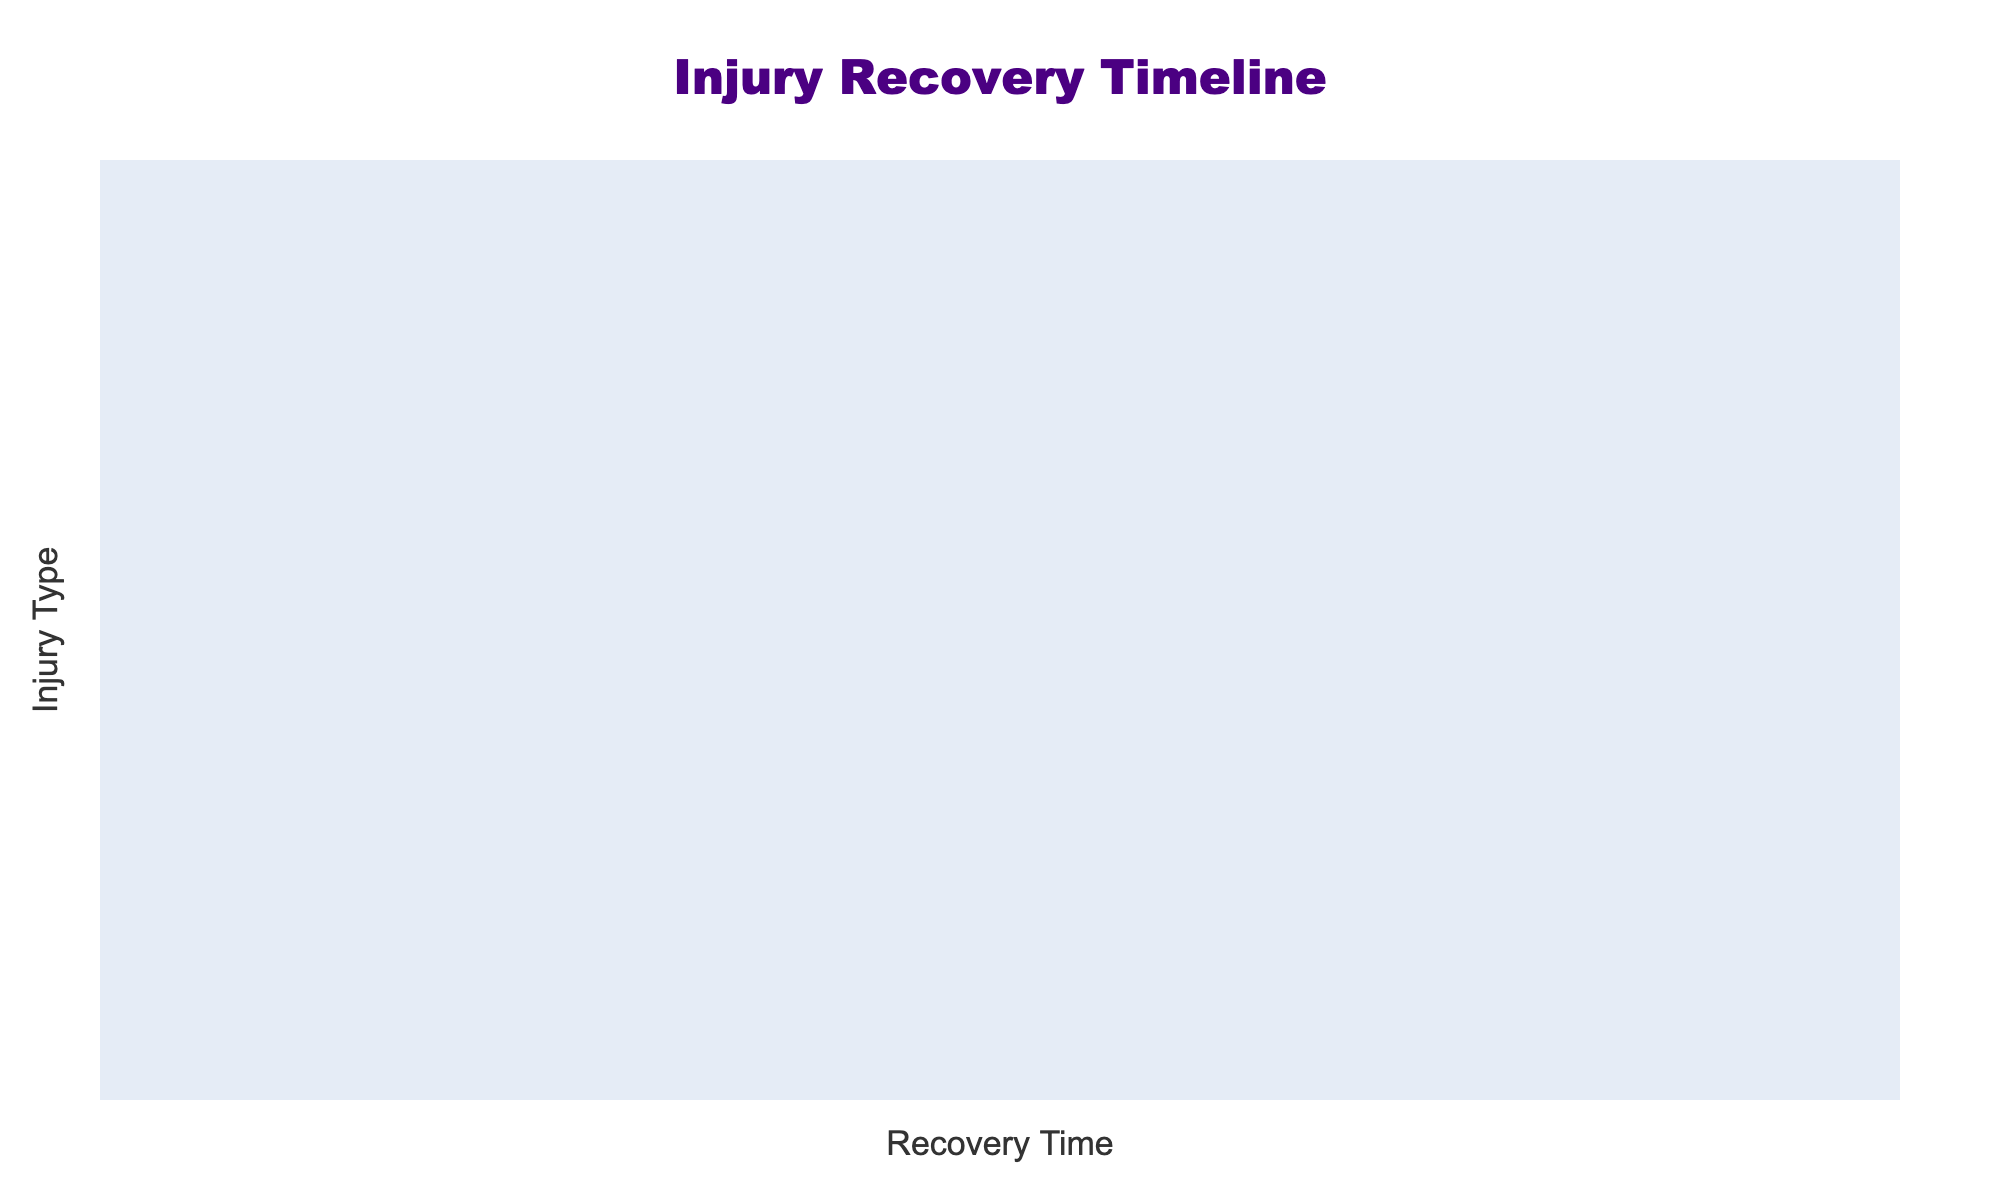What is the recovery percentage for an ankle sprain after 2 weeks? The table shows that the recovery percentage for an ankle sprain after 2 weeks is 60%.
Answer: 60% Which injury has the slowest initial recovery after 1 week? Observing the recovery percentages at 1 week, the ACL Tear shows 0% recovery, which is the lowest compared to other injuries.
Answer: ACL Tear What is the recovery percentage for a hamstring strain after 8 weeks, and how does it compare to a groin strain? The recovery percentage for a hamstring strain after 8 weeks is 90%, while the groin strain has a recovery percentage of 95% at the same time. Thus, the groin strain has a 5% higher recovery percentage than the hamstring strain after 8 weeks.
Answer: Hamstring Strain: 90%, Groin Strain: 95% True or False: A fractured collarbone has a 60% recovery after 8 weeks. The table indicates that a fractured collarbone has a recovery percentage of 60% after 8 weeks, making the statement true.
Answer: True What is the difference in recovery percentages between a concussion and a meniscus tear at 4 weeks? The concussion recovery rate at 4 weeks is 80%, while the meniscus tear is at 40%. The difference is calculated as 80% - 40% = 40%.
Answer: 40% List the two injuries with identical recovery percentages at 16 weeks. On checking the table, both the ACL Tear and the MCL Sprain both have a recovery percentage of 100% after 16 weeks.
Answer: ACL Tear and MCL Sprain What percentage of recovery can be expected for a shoulder dislocation after 32 weeks? The table reveals that the recovery percentage for a shoulder dislocation after 32 weeks is 100%.
Answer: 100% If a player has a quad contusion, how much recovery can they expect at the 8-week mark compared to an ankle sprain? The quad contusion has a recovery percentage of 100% at 8 weeks, whereas the ankle sprain has 100% recovery as well, making both injuries recover fully within this timeframe.
Answer: Both 100% Which injury has the highest recovery percentage after 1 week? The table shows that the highest recovery percentage after 1 week is 40% for a quad contusion.
Answer: 40% After how many weeks does a meniscus tear reach 100% recovery? According to the table, the meniscus tear reaches 100% recovery after 16 weeks.
Answer: 16 Weeks 